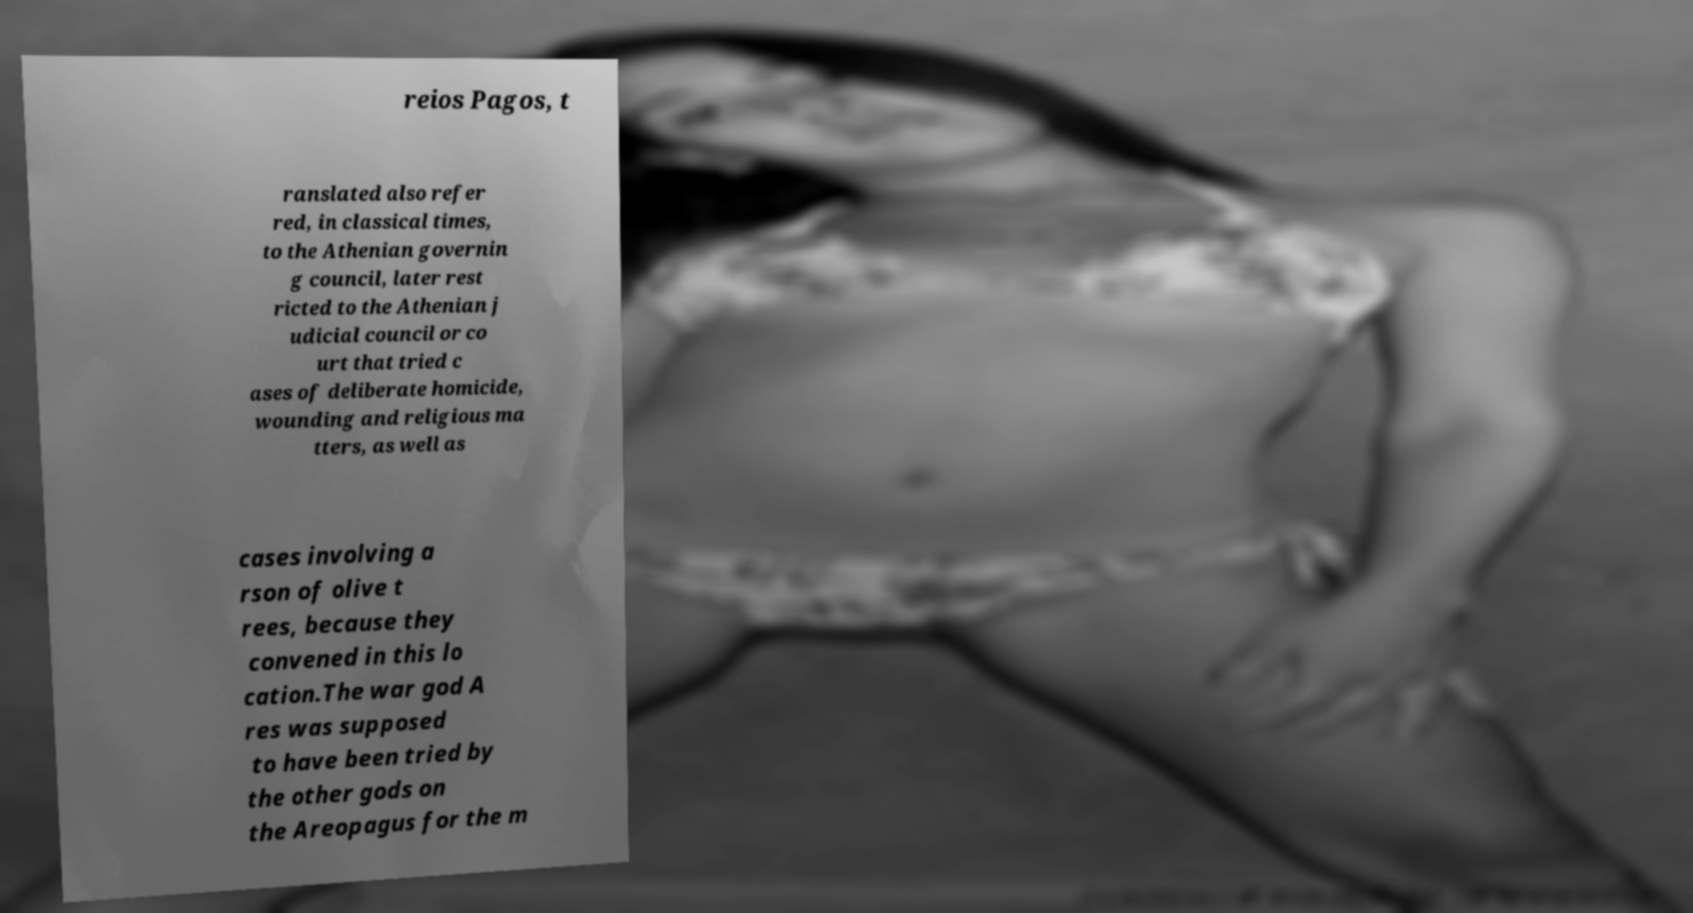Please identify and transcribe the text found in this image. reios Pagos, t ranslated also refer red, in classical times, to the Athenian governin g council, later rest ricted to the Athenian j udicial council or co urt that tried c ases of deliberate homicide, wounding and religious ma tters, as well as cases involving a rson of olive t rees, because they convened in this lo cation.The war god A res was supposed to have been tried by the other gods on the Areopagus for the m 